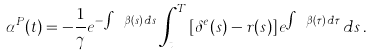Convert formula to latex. <formula><loc_0><loc_0><loc_500><loc_500>\alpha ^ { P } ( t ) = - \frac { 1 } { \gamma } e ^ { - \int _ { t } ^ { T } \beta ( s ) \, d s } \int _ { t } ^ { T } \left [ \delta ^ { e } ( s ) - r ( s ) \right ] e ^ { \int _ { s } ^ { T } \beta ( \tau ) \, d \tau } \, d s \, .</formula> 